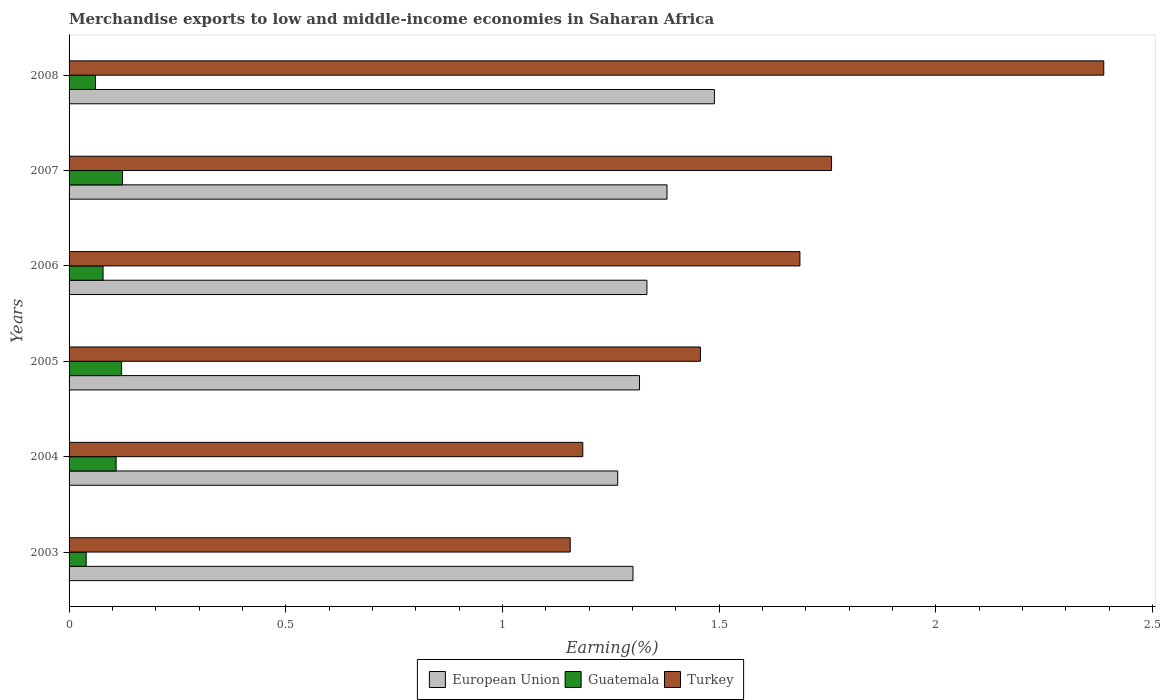How many bars are there on the 5th tick from the bottom?
Keep it short and to the point. 3. What is the label of the 6th group of bars from the top?
Offer a very short reply. 2003. In how many cases, is the number of bars for a given year not equal to the number of legend labels?
Your response must be concise. 0. What is the percentage of amount earned from merchandise exports in Guatemala in 2004?
Your answer should be very brief. 0.11. Across all years, what is the maximum percentage of amount earned from merchandise exports in European Union?
Offer a very short reply. 1.49. Across all years, what is the minimum percentage of amount earned from merchandise exports in Turkey?
Your answer should be very brief. 1.16. In which year was the percentage of amount earned from merchandise exports in Turkey minimum?
Provide a succinct answer. 2003. What is the total percentage of amount earned from merchandise exports in Turkey in the graph?
Your answer should be compact. 9.63. What is the difference between the percentage of amount earned from merchandise exports in European Union in 2003 and that in 2008?
Ensure brevity in your answer.  -0.19. What is the difference between the percentage of amount earned from merchandise exports in Guatemala in 2005 and the percentage of amount earned from merchandise exports in European Union in 2007?
Your response must be concise. -1.26. What is the average percentage of amount earned from merchandise exports in European Union per year?
Offer a terse response. 1.35. In the year 2007, what is the difference between the percentage of amount earned from merchandise exports in European Union and percentage of amount earned from merchandise exports in Guatemala?
Your answer should be compact. 1.26. In how many years, is the percentage of amount earned from merchandise exports in Guatemala greater than 0.4 %?
Keep it short and to the point. 0. What is the ratio of the percentage of amount earned from merchandise exports in Turkey in 2003 to that in 2006?
Your response must be concise. 0.69. What is the difference between the highest and the second highest percentage of amount earned from merchandise exports in European Union?
Offer a very short reply. 0.11. What is the difference between the highest and the lowest percentage of amount earned from merchandise exports in Turkey?
Offer a very short reply. 1.23. What does the 3rd bar from the bottom in 2004 represents?
Give a very brief answer. Turkey. Is it the case that in every year, the sum of the percentage of amount earned from merchandise exports in European Union and percentage of amount earned from merchandise exports in Guatemala is greater than the percentage of amount earned from merchandise exports in Turkey?
Provide a succinct answer. No. What is the difference between two consecutive major ticks on the X-axis?
Provide a short and direct response. 0.5. Are the values on the major ticks of X-axis written in scientific E-notation?
Provide a succinct answer. No. Where does the legend appear in the graph?
Your answer should be compact. Bottom center. How are the legend labels stacked?
Ensure brevity in your answer.  Horizontal. What is the title of the graph?
Make the answer very short. Merchandise exports to low and middle-income economies in Saharan Africa. What is the label or title of the X-axis?
Make the answer very short. Earning(%). What is the Earning(%) of European Union in 2003?
Your response must be concise. 1.3. What is the Earning(%) of Guatemala in 2003?
Give a very brief answer. 0.04. What is the Earning(%) of Turkey in 2003?
Offer a terse response. 1.16. What is the Earning(%) in European Union in 2004?
Offer a terse response. 1.27. What is the Earning(%) of Guatemala in 2004?
Give a very brief answer. 0.11. What is the Earning(%) of Turkey in 2004?
Ensure brevity in your answer.  1.19. What is the Earning(%) of European Union in 2005?
Make the answer very short. 1.32. What is the Earning(%) in Guatemala in 2005?
Ensure brevity in your answer.  0.12. What is the Earning(%) of Turkey in 2005?
Your answer should be very brief. 1.46. What is the Earning(%) in European Union in 2006?
Keep it short and to the point. 1.33. What is the Earning(%) of Guatemala in 2006?
Provide a short and direct response. 0.08. What is the Earning(%) in Turkey in 2006?
Ensure brevity in your answer.  1.69. What is the Earning(%) in European Union in 2007?
Ensure brevity in your answer.  1.38. What is the Earning(%) in Guatemala in 2007?
Keep it short and to the point. 0.12. What is the Earning(%) of Turkey in 2007?
Ensure brevity in your answer.  1.76. What is the Earning(%) of European Union in 2008?
Your response must be concise. 1.49. What is the Earning(%) of Guatemala in 2008?
Offer a very short reply. 0.06. What is the Earning(%) of Turkey in 2008?
Ensure brevity in your answer.  2.39. Across all years, what is the maximum Earning(%) of European Union?
Provide a short and direct response. 1.49. Across all years, what is the maximum Earning(%) of Guatemala?
Give a very brief answer. 0.12. Across all years, what is the maximum Earning(%) of Turkey?
Offer a terse response. 2.39. Across all years, what is the minimum Earning(%) in European Union?
Your answer should be very brief. 1.27. Across all years, what is the minimum Earning(%) of Guatemala?
Your response must be concise. 0.04. Across all years, what is the minimum Earning(%) of Turkey?
Keep it short and to the point. 1.16. What is the total Earning(%) in European Union in the graph?
Provide a succinct answer. 8.09. What is the total Earning(%) of Guatemala in the graph?
Keep it short and to the point. 0.53. What is the total Earning(%) of Turkey in the graph?
Offer a terse response. 9.63. What is the difference between the Earning(%) in European Union in 2003 and that in 2004?
Offer a terse response. 0.04. What is the difference between the Earning(%) of Guatemala in 2003 and that in 2004?
Your response must be concise. -0.07. What is the difference between the Earning(%) of Turkey in 2003 and that in 2004?
Your response must be concise. -0.03. What is the difference between the Earning(%) of European Union in 2003 and that in 2005?
Give a very brief answer. -0.02. What is the difference between the Earning(%) in Guatemala in 2003 and that in 2005?
Make the answer very short. -0.08. What is the difference between the Earning(%) in Turkey in 2003 and that in 2005?
Your answer should be very brief. -0.3. What is the difference between the Earning(%) of European Union in 2003 and that in 2006?
Your response must be concise. -0.03. What is the difference between the Earning(%) of Guatemala in 2003 and that in 2006?
Provide a succinct answer. -0.04. What is the difference between the Earning(%) of Turkey in 2003 and that in 2006?
Make the answer very short. -0.53. What is the difference between the Earning(%) in European Union in 2003 and that in 2007?
Provide a succinct answer. -0.08. What is the difference between the Earning(%) in Guatemala in 2003 and that in 2007?
Offer a very short reply. -0.08. What is the difference between the Earning(%) in Turkey in 2003 and that in 2007?
Your response must be concise. -0.6. What is the difference between the Earning(%) of European Union in 2003 and that in 2008?
Your response must be concise. -0.19. What is the difference between the Earning(%) of Guatemala in 2003 and that in 2008?
Keep it short and to the point. -0.02. What is the difference between the Earning(%) of Turkey in 2003 and that in 2008?
Keep it short and to the point. -1.23. What is the difference between the Earning(%) of European Union in 2004 and that in 2005?
Provide a succinct answer. -0.05. What is the difference between the Earning(%) of Guatemala in 2004 and that in 2005?
Your response must be concise. -0.01. What is the difference between the Earning(%) of Turkey in 2004 and that in 2005?
Give a very brief answer. -0.27. What is the difference between the Earning(%) in European Union in 2004 and that in 2006?
Provide a succinct answer. -0.07. What is the difference between the Earning(%) of Guatemala in 2004 and that in 2006?
Give a very brief answer. 0.03. What is the difference between the Earning(%) of Turkey in 2004 and that in 2006?
Keep it short and to the point. -0.5. What is the difference between the Earning(%) of European Union in 2004 and that in 2007?
Ensure brevity in your answer.  -0.11. What is the difference between the Earning(%) in Guatemala in 2004 and that in 2007?
Offer a very short reply. -0.01. What is the difference between the Earning(%) in Turkey in 2004 and that in 2007?
Your answer should be compact. -0.57. What is the difference between the Earning(%) in European Union in 2004 and that in 2008?
Provide a succinct answer. -0.22. What is the difference between the Earning(%) of Guatemala in 2004 and that in 2008?
Provide a short and direct response. 0.05. What is the difference between the Earning(%) of Turkey in 2004 and that in 2008?
Keep it short and to the point. -1.2. What is the difference between the Earning(%) in European Union in 2005 and that in 2006?
Your answer should be very brief. -0.02. What is the difference between the Earning(%) of Guatemala in 2005 and that in 2006?
Make the answer very short. 0.04. What is the difference between the Earning(%) in Turkey in 2005 and that in 2006?
Your answer should be very brief. -0.23. What is the difference between the Earning(%) of European Union in 2005 and that in 2007?
Your response must be concise. -0.06. What is the difference between the Earning(%) in Guatemala in 2005 and that in 2007?
Your answer should be very brief. -0. What is the difference between the Earning(%) of Turkey in 2005 and that in 2007?
Ensure brevity in your answer.  -0.3. What is the difference between the Earning(%) in European Union in 2005 and that in 2008?
Your answer should be compact. -0.17. What is the difference between the Earning(%) in Guatemala in 2005 and that in 2008?
Provide a succinct answer. 0.06. What is the difference between the Earning(%) of Turkey in 2005 and that in 2008?
Your response must be concise. -0.93. What is the difference between the Earning(%) of European Union in 2006 and that in 2007?
Offer a terse response. -0.05. What is the difference between the Earning(%) of Guatemala in 2006 and that in 2007?
Offer a very short reply. -0.04. What is the difference between the Earning(%) in Turkey in 2006 and that in 2007?
Provide a succinct answer. -0.07. What is the difference between the Earning(%) in European Union in 2006 and that in 2008?
Your response must be concise. -0.16. What is the difference between the Earning(%) of Guatemala in 2006 and that in 2008?
Provide a short and direct response. 0.02. What is the difference between the Earning(%) of Turkey in 2006 and that in 2008?
Your answer should be compact. -0.7. What is the difference between the Earning(%) of European Union in 2007 and that in 2008?
Provide a succinct answer. -0.11. What is the difference between the Earning(%) of Guatemala in 2007 and that in 2008?
Your answer should be very brief. 0.06. What is the difference between the Earning(%) in Turkey in 2007 and that in 2008?
Give a very brief answer. -0.63. What is the difference between the Earning(%) of European Union in 2003 and the Earning(%) of Guatemala in 2004?
Offer a very short reply. 1.19. What is the difference between the Earning(%) of European Union in 2003 and the Earning(%) of Turkey in 2004?
Offer a very short reply. 0.12. What is the difference between the Earning(%) in Guatemala in 2003 and the Earning(%) in Turkey in 2004?
Ensure brevity in your answer.  -1.15. What is the difference between the Earning(%) of European Union in 2003 and the Earning(%) of Guatemala in 2005?
Provide a succinct answer. 1.18. What is the difference between the Earning(%) in European Union in 2003 and the Earning(%) in Turkey in 2005?
Your response must be concise. -0.16. What is the difference between the Earning(%) of Guatemala in 2003 and the Earning(%) of Turkey in 2005?
Provide a short and direct response. -1.42. What is the difference between the Earning(%) of European Union in 2003 and the Earning(%) of Guatemala in 2006?
Give a very brief answer. 1.22. What is the difference between the Earning(%) in European Union in 2003 and the Earning(%) in Turkey in 2006?
Your answer should be very brief. -0.39. What is the difference between the Earning(%) of Guatemala in 2003 and the Earning(%) of Turkey in 2006?
Make the answer very short. -1.65. What is the difference between the Earning(%) of European Union in 2003 and the Earning(%) of Guatemala in 2007?
Give a very brief answer. 1.18. What is the difference between the Earning(%) in European Union in 2003 and the Earning(%) in Turkey in 2007?
Offer a terse response. -0.46. What is the difference between the Earning(%) of Guatemala in 2003 and the Earning(%) of Turkey in 2007?
Give a very brief answer. -1.72. What is the difference between the Earning(%) in European Union in 2003 and the Earning(%) in Guatemala in 2008?
Your answer should be very brief. 1.24. What is the difference between the Earning(%) of European Union in 2003 and the Earning(%) of Turkey in 2008?
Make the answer very short. -1.09. What is the difference between the Earning(%) in Guatemala in 2003 and the Earning(%) in Turkey in 2008?
Provide a succinct answer. -2.35. What is the difference between the Earning(%) of European Union in 2004 and the Earning(%) of Guatemala in 2005?
Give a very brief answer. 1.14. What is the difference between the Earning(%) in European Union in 2004 and the Earning(%) in Turkey in 2005?
Offer a very short reply. -0.19. What is the difference between the Earning(%) in Guatemala in 2004 and the Earning(%) in Turkey in 2005?
Your response must be concise. -1.35. What is the difference between the Earning(%) of European Union in 2004 and the Earning(%) of Guatemala in 2006?
Your answer should be very brief. 1.19. What is the difference between the Earning(%) in European Union in 2004 and the Earning(%) in Turkey in 2006?
Offer a terse response. -0.42. What is the difference between the Earning(%) of Guatemala in 2004 and the Earning(%) of Turkey in 2006?
Your response must be concise. -1.58. What is the difference between the Earning(%) of European Union in 2004 and the Earning(%) of Guatemala in 2007?
Your response must be concise. 1.14. What is the difference between the Earning(%) of European Union in 2004 and the Earning(%) of Turkey in 2007?
Keep it short and to the point. -0.49. What is the difference between the Earning(%) in Guatemala in 2004 and the Earning(%) in Turkey in 2007?
Provide a succinct answer. -1.65. What is the difference between the Earning(%) of European Union in 2004 and the Earning(%) of Guatemala in 2008?
Ensure brevity in your answer.  1.21. What is the difference between the Earning(%) in European Union in 2004 and the Earning(%) in Turkey in 2008?
Provide a succinct answer. -1.12. What is the difference between the Earning(%) of Guatemala in 2004 and the Earning(%) of Turkey in 2008?
Provide a succinct answer. -2.28. What is the difference between the Earning(%) in European Union in 2005 and the Earning(%) in Guatemala in 2006?
Make the answer very short. 1.24. What is the difference between the Earning(%) of European Union in 2005 and the Earning(%) of Turkey in 2006?
Give a very brief answer. -0.37. What is the difference between the Earning(%) of Guatemala in 2005 and the Earning(%) of Turkey in 2006?
Your answer should be very brief. -1.57. What is the difference between the Earning(%) of European Union in 2005 and the Earning(%) of Guatemala in 2007?
Your answer should be very brief. 1.19. What is the difference between the Earning(%) in European Union in 2005 and the Earning(%) in Turkey in 2007?
Your answer should be compact. -0.44. What is the difference between the Earning(%) in Guatemala in 2005 and the Earning(%) in Turkey in 2007?
Your response must be concise. -1.64. What is the difference between the Earning(%) in European Union in 2005 and the Earning(%) in Guatemala in 2008?
Your answer should be very brief. 1.26. What is the difference between the Earning(%) of European Union in 2005 and the Earning(%) of Turkey in 2008?
Your response must be concise. -1.07. What is the difference between the Earning(%) of Guatemala in 2005 and the Earning(%) of Turkey in 2008?
Offer a terse response. -2.27. What is the difference between the Earning(%) of European Union in 2006 and the Earning(%) of Guatemala in 2007?
Provide a succinct answer. 1.21. What is the difference between the Earning(%) of European Union in 2006 and the Earning(%) of Turkey in 2007?
Your response must be concise. -0.43. What is the difference between the Earning(%) of Guatemala in 2006 and the Earning(%) of Turkey in 2007?
Provide a succinct answer. -1.68. What is the difference between the Earning(%) in European Union in 2006 and the Earning(%) in Guatemala in 2008?
Offer a terse response. 1.27. What is the difference between the Earning(%) of European Union in 2006 and the Earning(%) of Turkey in 2008?
Ensure brevity in your answer.  -1.05. What is the difference between the Earning(%) of Guatemala in 2006 and the Earning(%) of Turkey in 2008?
Give a very brief answer. -2.31. What is the difference between the Earning(%) of European Union in 2007 and the Earning(%) of Guatemala in 2008?
Your response must be concise. 1.32. What is the difference between the Earning(%) in European Union in 2007 and the Earning(%) in Turkey in 2008?
Your answer should be very brief. -1.01. What is the difference between the Earning(%) of Guatemala in 2007 and the Earning(%) of Turkey in 2008?
Provide a succinct answer. -2.26. What is the average Earning(%) in European Union per year?
Provide a short and direct response. 1.35. What is the average Earning(%) in Guatemala per year?
Make the answer very short. 0.09. What is the average Earning(%) in Turkey per year?
Make the answer very short. 1.61. In the year 2003, what is the difference between the Earning(%) in European Union and Earning(%) in Guatemala?
Offer a very short reply. 1.26. In the year 2003, what is the difference between the Earning(%) in European Union and Earning(%) in Turkey?
Give a very brief answer. 0.14. In the year 2003, what is the difference between the Earning(%) of Guatemala and Earning(%) of Turkey?
Your response must be concise. -1.12. In the year 2004, what is the difference between the Earning(%) in European Union and Earning(%) in Guatemala?
Offer a very short reply. 1.16. In the year 2004, what is the difference between the Earning(%) in European Union and Earning(%) in Turkey?
Your answer should be compact. 0.08. In the year 2004, what is the difference between the Earning(%) of Guatemala and Earning(%) of Turkey?
Your answer should be compact. -1.08. In the year 2005, what is the difference between the Earning(%) in European Union and Earning(%) in Guatemala?
Provide a short and direct response. 1.2. In the year 2005, what is the difference between the Earning(%) in European Union and Earning(%) in Turkey?
Provide a short and direct response. -0.14. In the year 2005, what is the difference between the Earning(%) of Guatemala and Earning(%) of Turkey?
Offer a very short reply. -1.34. In the year 2006, what is the difference between the Earning(%) of European Union and Earning(%) of Guatemala?
Provide a short and direct response. 1.25. In the year 2006, what is the difference between the Earning(%) of European Union and Earning(%) of Turkey?
Your answer should be very brief. -0.35. In the year 2006, what is the difference between the Earning(%) in Guatemala and Earning(%) in Turkey?
Ensure brevity in your answer.  -1.61. In the year 2007, what is the difference between the Earning(%) of European Union and Earning(%) of Guatemala?
Your response must be concise. 1.26. In the year 2007, what is the difference between the Earning(%) of European Union and Earning(%) of Turkey?
Ensure brevity in your answer.  -0.38. In the year 2007, what is the difference between the Earning(%) in Guatemala and Earning(%) in Turkey?
Offer a terse response. -1.64. In the year 2008, what is the difference between the Earning(%) in European Union and Earning(%) in Guatemala?
Your answer should be very brief. 1.43. In the year 2008, what is the difference between the Earning(%) of European Union and Earning(%) of Turkey?
Your response must be concise. -0.9. In the year 2008, what is the difference between the Earning(%) in Guatemala and Earning(%) in Turkey?
Ensure brevity in your answer.  -2.33. What is the ratio of the Earning(%) of European Union in 2003 to that in 2004?
Give a very brief answer. 1.03. What is the ratio of the Earning(%) of Guatemala in 2003 to that in 2004?
Give a very brief answer. 0.36. What is the ratio of the Earning(%) of Turkey in 2003 to that in 2004?
Your answer should be compact. 0.98. What is the ratio of the Earning(%) in Guatemala in 2003 to that in 2005?
Offer a terse response. 0.33. What is the ratio of the Earning(%) of Turkey in 2003 to that in 2005?
Ensure brevity in your answer.  0.79. What is the ratio of the Earning(%) of European Union in 2003 to that in 2006?
Ensure brevity in your answer.  0.98. What is the ratio of the Earning(%) of Guatemala in 2003 to that in 2006?
Keep it short and to the point. 0.5. What is the ratio of the Earning(%) of Turkey in 2003 to that in 2006?
Offer a very short reply. 0.69. What is the ratio of the Earning(%) of European Union in 2003 to that in 2007?
Offer a very short reply. 0.94. What is the ratio of the Earning(%) of Guatemala in 2003 to that in 2007?
Your response must be concise. 0.32. What is the ratio of the Earning(%) in Turkey in 2003 to that in 2007?
Your answer should be compact. 0.66. What is the ratio of the Earning(%) in European Union in 2003 to that in 2008?
Make the answer very short. 0.87. What is the ratio of the Earning(%) in Guatemala in 2003 to that in 2008?
Keep it short and to the point. 0.65. What is the ratio of the Earning(%) of Turkey in 2003 to that in 2008?
Provide a succinct answer. 0.48. What is the ratio of the Earning(%) in European Union in 2004 to that in 2005?
Keep it short and to the point. 0.96. What is the ratio of the Earning(%) of Guatemala in 2004 to that in 2005?
Offer a very short reply. 0.9. What is the ratio of the Earning(%) in Turkey in 2004 to that in 2005?
Provide a succinct answer. 0.81. What is the ratio of the Earning(%) of European Union in 2004 to that in 2006?
Offer a very short reply. 0.95. What is the ratio of the Earning(%) of Guatemala in 2004 to that in 2006?
Your response must be concise. 1.38. What is the ratio of the Earning(%) of Turkey in 2004 to that in 2006?
Make the answer very short. 0.7. What is the ratio of the Earning(%) in European Union in 2004 to that in 2007?
Provide a succinct answer. 0.92. What is the ratio of the Earning(%) of Guatemala in 2004 to that in 2007?
Give a very brief answer. 0.88. What is the ratio of the Earning(%) in Turkey in 2004 to that in 2007?
Keep it short and to the point. 0.67. What is the ratio of the Earning(%) in European Union in 2004 to that in 2008?
Your answer should be very brief. 0.85. What is the ratio of the Earning(%) in Guatemala in 2004 to that in 2008?
Offer a very short reply. 1.78. What is the ratio of the Earning(%) in Turkey in 2004 to that in 2008?
Your response must be concise. 0.5. What is the ratio of the Earning(%) of European Union in 2005 to that in 2006?
Give a very brief answer. 0.99. What is the ratio of the Earning(%) in Guatemala in 2005 to that in 2006?
Offer a very short reply. 1.55. What is the ratio of the Earning(%) of Turkey in 2005 to that in 2006?
Your answer should be very brief. 0.86. What is the ratio of the Earning(%) of European Union in 2005 to that in 2007?
Your answer should be compact. 0.95. What is the ratio of the Earning(%) in Guatemala in 2005 to that in 2007?
Provide a succinct answer. 0.98. What is the ratio of the Earning(%) in Turkey in 2005 to that in 2007?
Provide a succinct answer. 0.83. What is the ratio of the Earning(%) in European Union in 2005 to that in 2008?
Provide a short and direct response. 0.88. What is the ratio of the Earning(%) in Guatemala in 2005 to that in 2008?
Provide a short and direct response. 1.99. What is the ratio of the Earning(%) of Turkey in 2005 to that in 2008?
Offer a very short reply. 0.61. What is the ratio of the Earning(%) of European Union in 2006 to that in 2007?
Your response must be concise. 0.97. What is the ratio of the Earning(%) in Guatemala in 2006 to that in 2007?
Your response must be concise. 0.64. What is the ratio of the Earning(%) in Turkey in 2006 to that in 2007?
Provide a short and direct response. 0.96. What is the ratio of the Earning(%) in European Union in 2006 to that in 2008?
Ensure brevity in your answer.  0.9. What is the ratio of the Earning(%) in Guatemala in 2006 to that in 2008?
Your response must be concise. 1.29. What is the ratio of the Earning(%) of Turkey in 2006 to that in 2008?
Your answer should be compact. 0.71. What is the ratio of the Earning(%) in European Union in 2007 to that in 2008?
Your answer should be compact. 0.93. What is the ratio of the Earning(%) of Guatemala in 2007 to that in 2008?
Give a very brief answer. 2.02. What is the ratio of the Earning(%) of Turkey in 2007 to that in 2008?
Offer a terse response. 0.74. What is the difference between the highest and the second highest Earning(%) in European Union?
Your answer should be very brief. 0.11. What is the difference between the highest and the second highest Earning(%) in Guatemala?
Provide a short and direct response. 0. What is the difference between the highest and the second highest Earning(%) of Turkey?
Keep it short and to the point. 0.63. What is the difference between the highest and the lowest Earning(%) in European Union?
Make the answer very short. 0.22. What is the difference between the highest and the lowest Earning(%) of Guatemala?
Keep it short and to the point. 0.08. What is the difference between the highest and the lowest Earning(%) in Turkey?
Your answer should be compact. 1.23. 